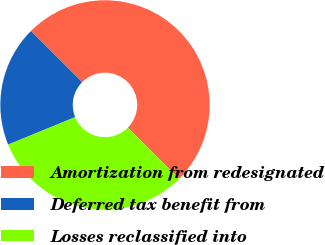Convert chart. <chart><loc_0><loc_0><loc_500><loc_500><pie_chart><fcel>Amortization from redesignated<fcel>Deferred tax benefit from<fcel>Losses reclassified into<nl><fcel>50.0%<fcel>18.67%<fcel>31.33%<nl></chart> 